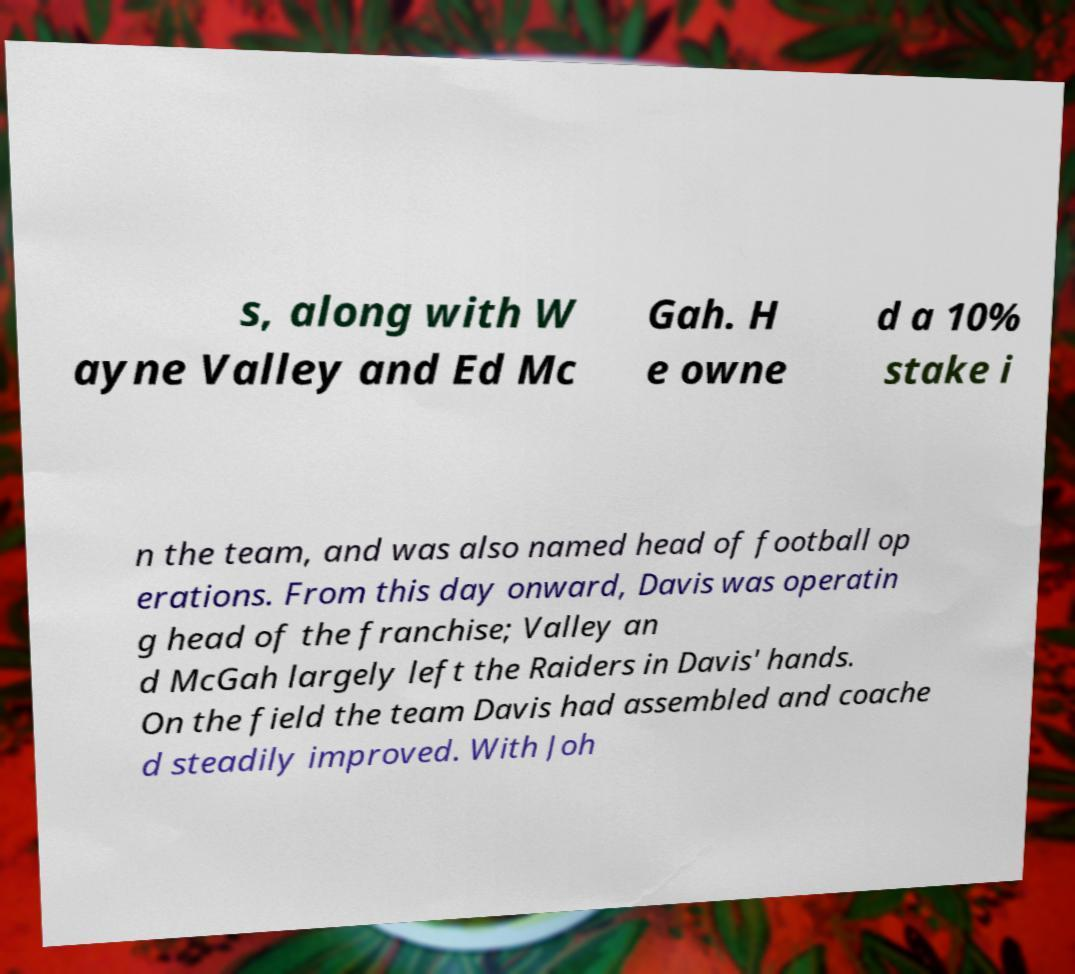Could you assist in decoding the text presented in this image and type it out clearly? s, along with W ayne Valley and Ed Mc Gah. H e owne d a 10% stake i n the team, and was also named head of football op erations. From this day onward, Davis was operatin g head of the franchise; Valley an d McGah largely left the Raiders in Davis' hands. On the field the team Davis had assembled and coache d steadily improved. With Joh 